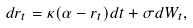<formula> <loc_0><loc_0><loc_500><loc_500>d r _ { t } = \kappa ( \alpha - r _ { t } ) d t + \sigma d W _ { t } ,</formula> 